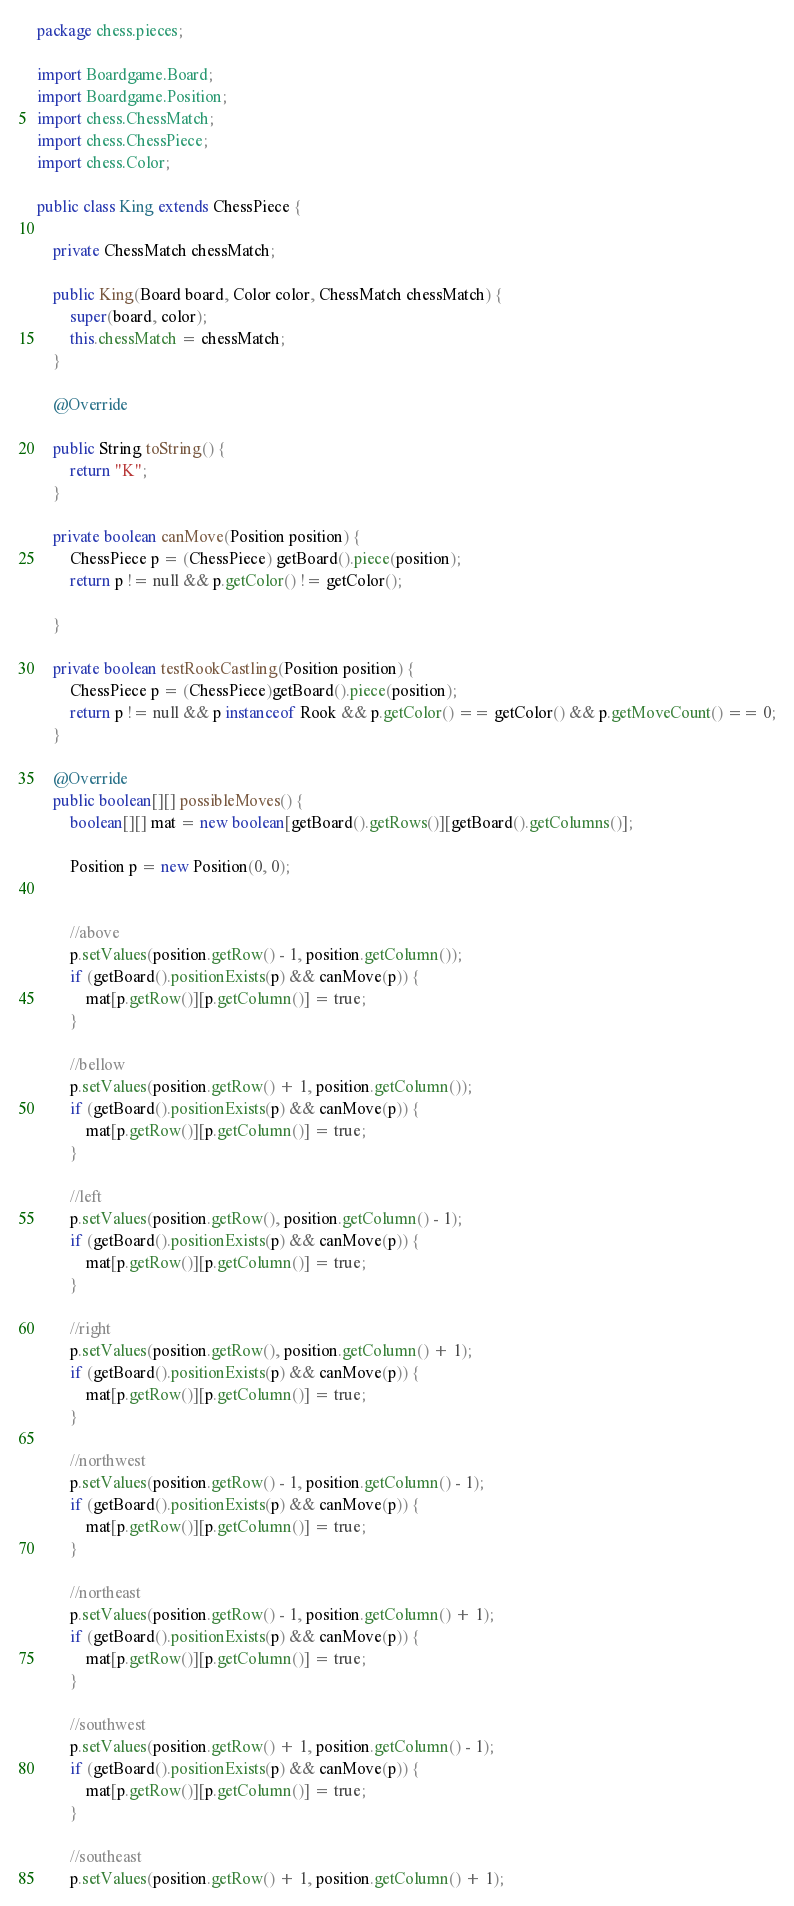<code> <loc_0><loc_0><loc_500><loc_500><_Java_>package chess.pieces;

import Boardgame.Board;
import Boardgame.Position;
import chess.ChessMatch;
import chess.ChessPiece;
import chess.Color;

public class King extends ChessPiece {
	
	private ChessMatch chessMatch;
	
    public King(Board board, Color color, ChessMatch chessMatch) {
        super(board, color);
        this.chessMatch = chessMatch;
    }

    @Override

    public String toString() {
        return "K";
    }

    private boolean canMove(Position position) {
        ChessPiece p = (ChessPiece) getBoard().piece(position);
        return p != null && p.getColor() != getColor();

    }
    
    private boolean testRookCastling(Position position) {
    	ChessPiece p = (ChessPiece)getBoard().piece(position);
    	return p != null && p instanceof Rook && p.getColor() == getColor() && p.getMoveCount() == 0;
    }

    @Override
    public boolean[][] possibleMoves() {
        boolean[][] mat = new boolean[getBoard().getRows()][getBoard().getColumns()];

        Position p = new Position(0, 0);


        //above
        p.setValues(position.getRow() - 1, position.getColumn());
        if (getBoard().positionExists(p) && canMove(p)) {
            mat[p.getRow()][p.getColumn()] = true;
        }

        //bellow
        p.setValues(position.getRow() + 1, position.getColumn());
        if (getBoard().positionExists(p) && canMove(p)) {
            mat[p.getRow()][p.getColumn()] = true;
        }

        //left
        p.setValues(position.getRow(), position.getColumn() - 1);
        if (getBoard().positionExists(p) && canMove(p)) {
            mat[p.getRow()][p.getColumn()] = true;
        }

        //right
        p.setValues(position.getRow(), position.getColumn() + 1);
        if (getBoard().positionExists(p) && canMove(p)) {
            mat[p.getRow()][p.getColumn()] = true;
        }

        //northwest
        p.setValues(position.getRow() - 1, position.getColumn() - 1);
        if (getBoard().positionExists(p) && canMove(p)) {
            mat[p.getRow()][p.getColumn()] = true;
        }

        //northeast
        p.setValues(position.getRow() - 1, position.getColumn() + 1);
        if (getBoard().positionExists(p) && canMove(p)) {
            mat[p.getRow()][p.getColumn()] = true;
        }

        //southwest
        p.setValues(position.getRow() + 1, position.getColumn() - 1);
        if (getBoard().positionExists(p) && canMove(p)) {
            mat[p.getRow()][p.getColumn()] = true;
        }

        //southeast
        p.setValues(position.getRow() + 1, position.getColumn() + 1);</code> 